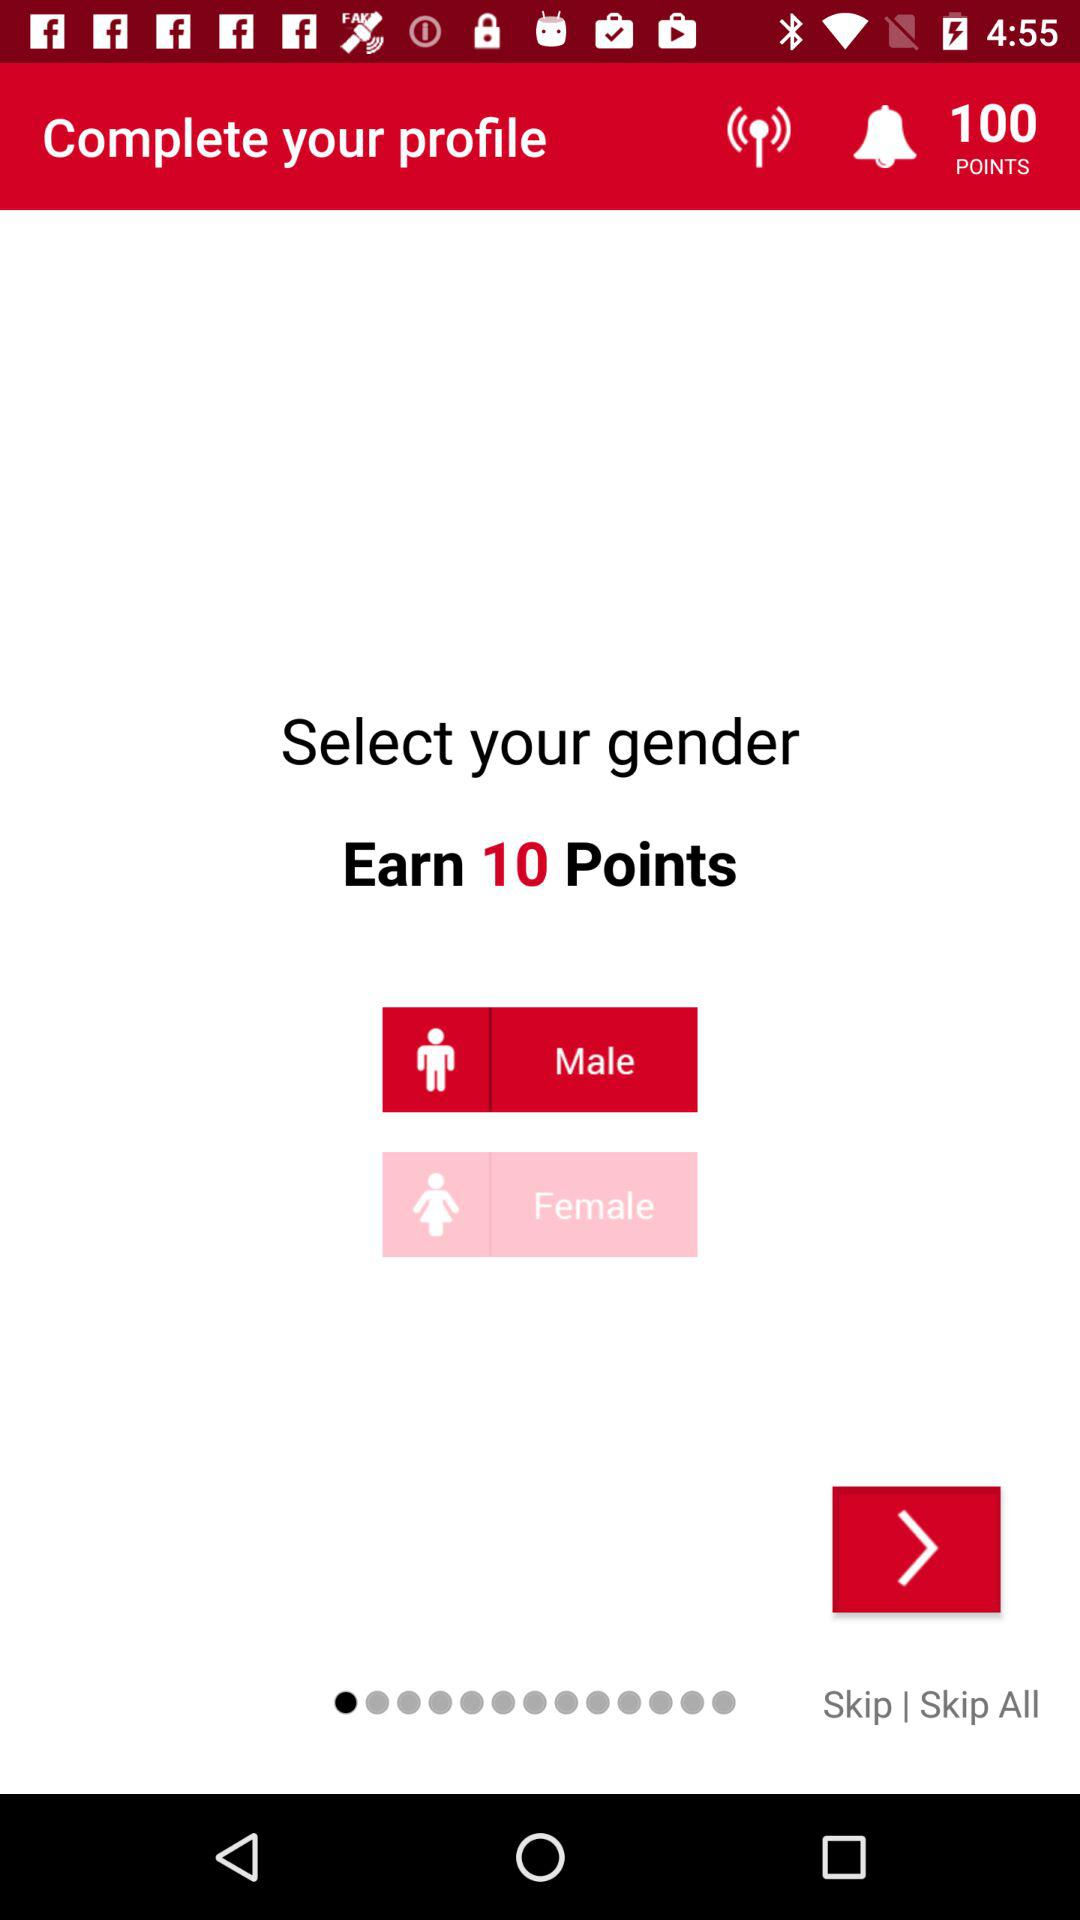Which gender is selected? The selected gender is male. 